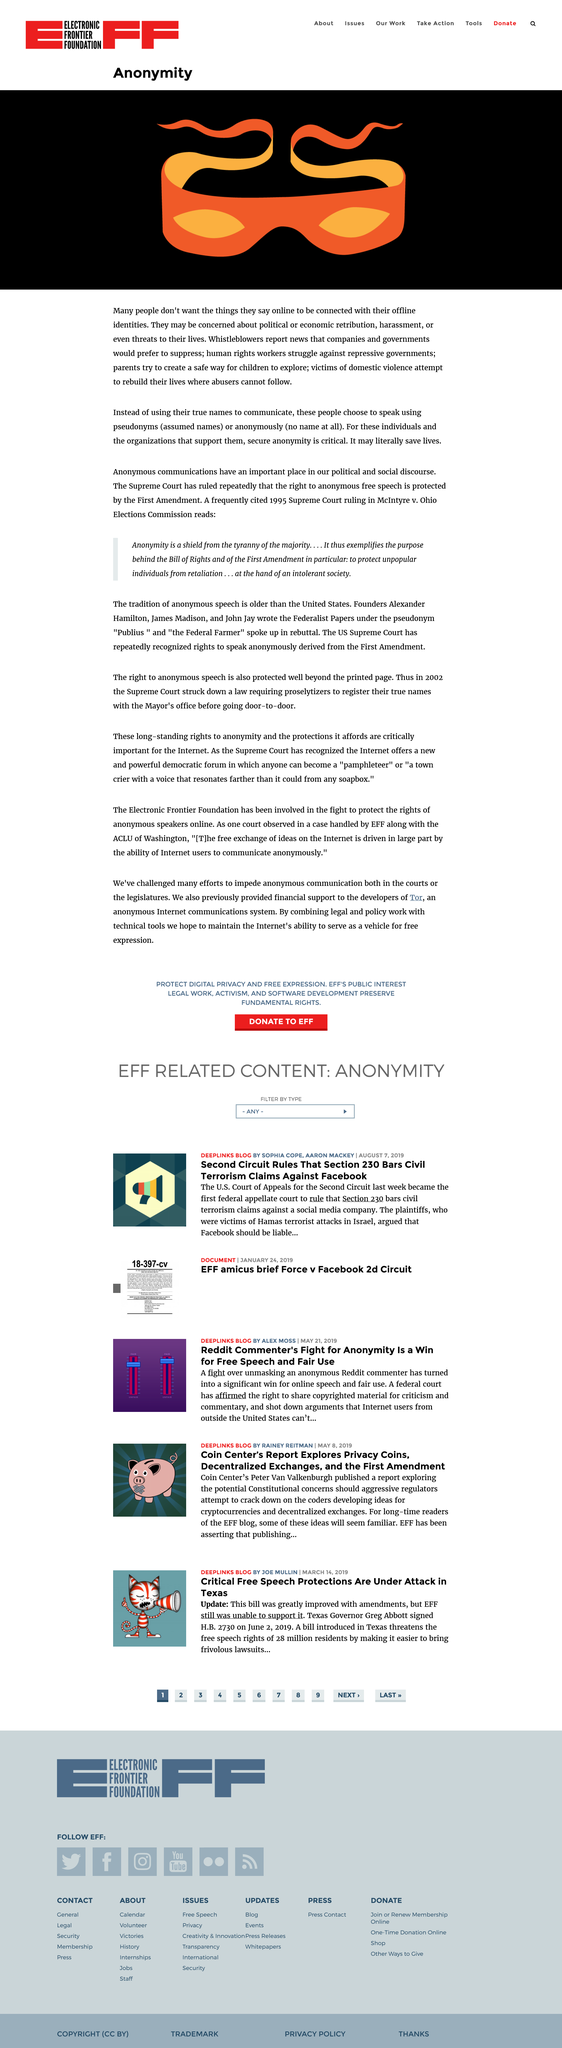Give some essential details in this illustration. Anonymity is crucial for victims of domestic violence as it allows them to rebuild their lives without fear of retaliation from their abusers. Many people choose to speak using pseudonyms or anonymously online to keep their anonymity. Whistleblowers report news that companies and governments seek to hide. 